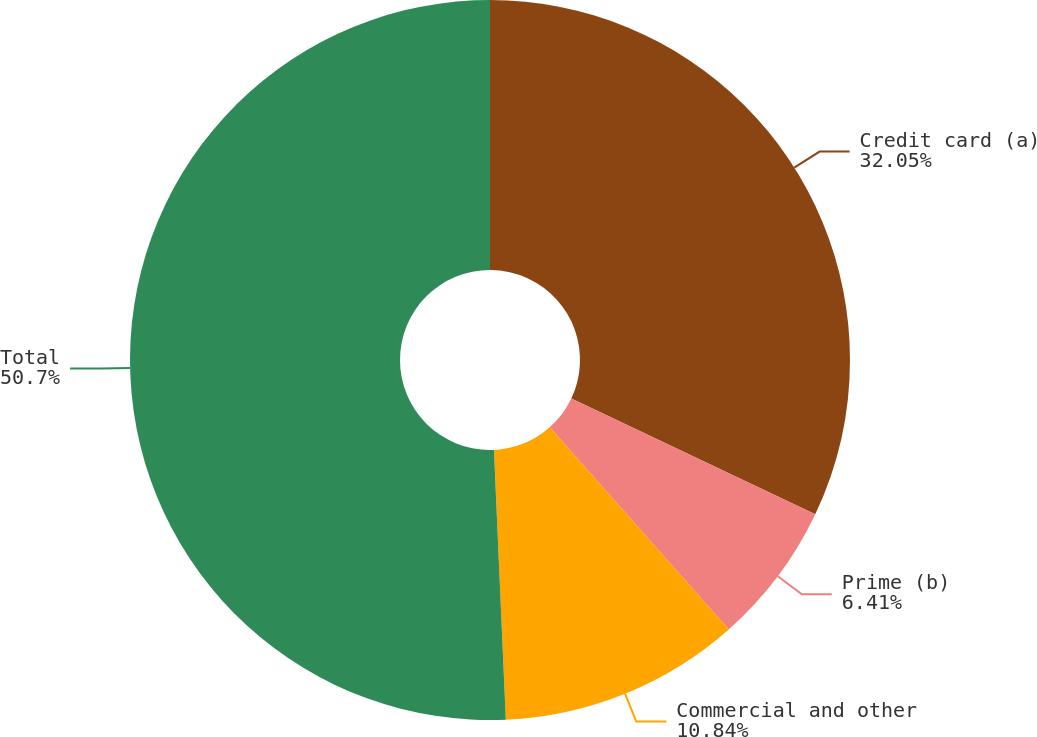Convert chart. <chart><loc_0><loc_0><loc_500><loc_500><pie_chart><fcel>Credit card (a)<fcel>Prime (b)<fcel>Commercial and other<fcel>Total<nl><fcel>32.05%<fcel>6.41%<fcel>10.84%<fcel>50.7%<nl></chart> 